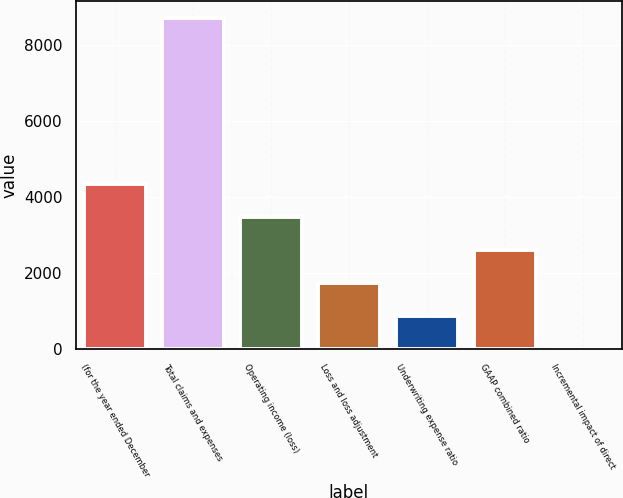Convert chart to OTSL. <chart><loc_0><loc_0><loc_500><loc_500><bar_chart><fcel>(for the year ended December<fcel>Total claims and expenses<fcel>Operating income (loss)<fcel>Loss and loss adjustment<fcel>Underwriting expense ratio<fcel>GAAP combined ratio<fcel>Incremental impact of direct<nl><fcel>4355.25<fcel>8708<fcel>3484.7<fcel>1743.6<fcel>873.05<fcel>2614.15<fcel>2.5<nl></chart> 